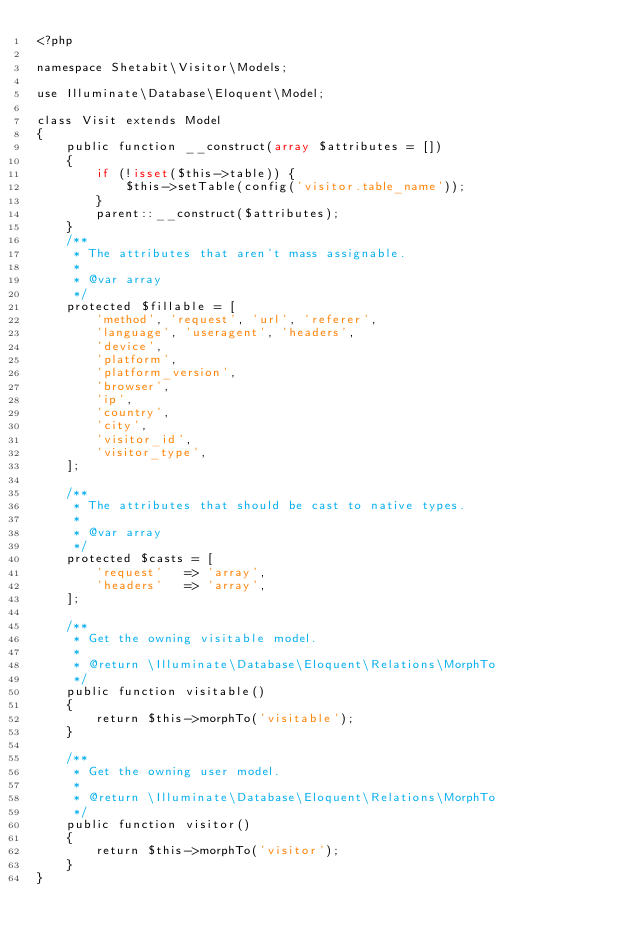<code> <loc_0><loc_0><loc_500><loc_500><_PHP_><?php

namespace Shetabit\Visitor\Models;

use Illuminate\Database\Eloquent\Model;

class Visit extends Model
{
    public function __construct(array $attributes = [])
    {
        if (!isset($this->table)) {
            $this->setTable(config('visitor.table_name'));
        }
        parent::__construct($attributes);
    }
    /**
     * The attributes that aren't mass assignable.
     *
     * @var array
     */
    protected $fillable = [
        'method', 'request', 'url', 'referer',
        'language', 'useragent', 'headers',
        'device',
        'platform',
        'platform_version',
        'browser',
        'ip',
        'country',
        'city',
        'visitor_id',
        'visitor_type',
    ];

    /**
     * The attributes that should be cast to native types.
     *
     * @var array
     */
    protected $casts = [
        'request'   => 'array',
        'headers'   => 'array',
    ];

    /**
     * Get the owning visitable model.
     *
     * @return \Illuminate\Database\Eloquent\Relations\MorphTo
     */
    public function visitable()
    {
        return $this->morphTo('visitable');
    }

    /**
     * Get the owning user model.
     *
     * @return \Illuminate\Database\Eloquent\Relations\MorphTo
     */
    public function visitor()
    {
        return $this->morphTo('visitor');
    }
}
</code> 